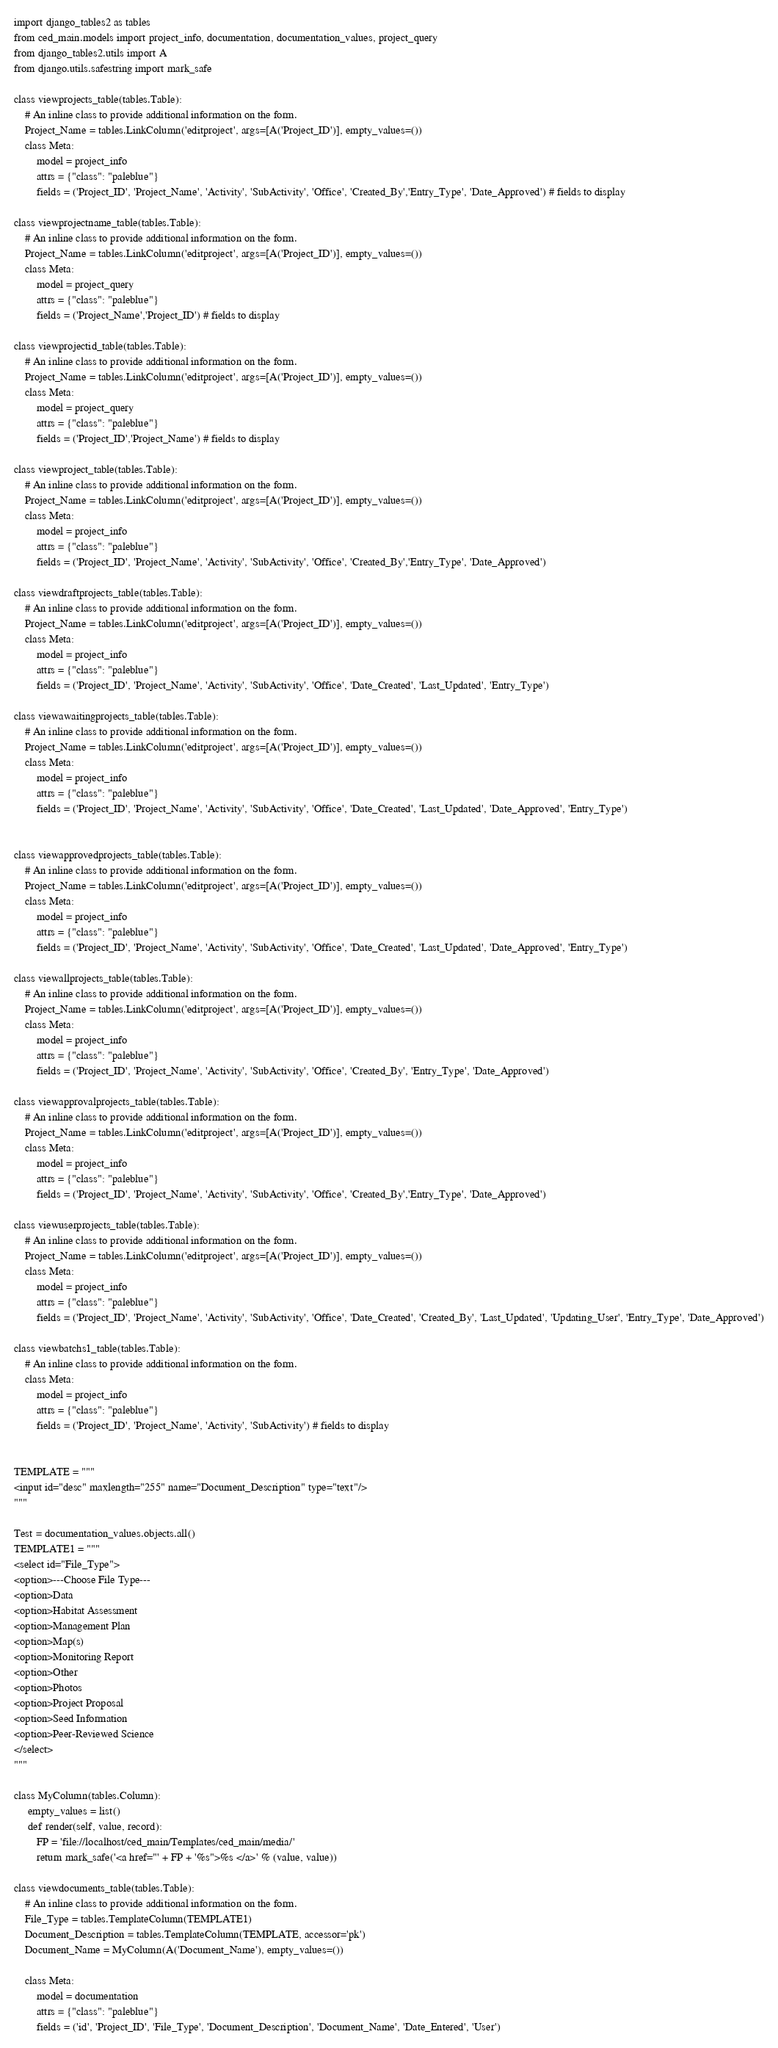<code> <loc_0><loc_0><loc_500><loc_500><_Python_>import django_tables2 as tables
from ced_main.models import project_info, documentation, documentation_values, project_query
from django_tables2.utils import A
from django.utils.safestring import mark_safe

class viewprojects_table(tables.Table):
    # An inline class to provide additional information on the form.
    Project_Name = tables.LinkColumn('editproject', args=[A('Project_ID')], empty_values=())
    class Meta:
        model = project_info
        attrs = {"class": "paleblue"}
        fields = ('Project_ID', 'Project_Name', 'Activity', 'SubActivity', 'Office', 'Created_By','Entry_Type', 'Date_Approved') # fields to display

class viewprojectname_table(tables.Table):
    # An inline class to provide additional information on the form.
    Project_Name = tables.LinkColumn('editproject', args=[A('Project_ID')], empty_values=())
    class Meta:
        model = project_query
        attrs = {"class": "paleblue"}
        fields = ('Project_Name','Project_ID') # fields to display

class viewprojectid_table(tables.Table):
    # An inline class to provide additional information on the form.
    Project_Name = tables.LinkColumn('editproject', args=[A('Project_ID')], empty_values=())
    class Meta:
        model = project_query
        attrs = {"class": "paleblue"}
        fields = ('Project_ID','Project_Name') # fields to display

class viewproject_table(tables.Table):
    # An inline class to provide additional information on the form.
    Project_Name = tables.LinkColumn('editproject', args=[A('Project_ID')], empty_values=())
    class Meta:
        model = project_info
        attrs = {"class": "paleblue"}
        fields = ('Project_ID', 'Project_Name', 'Activity', 'SubActivity', 'Office', 'Created_By','Entry_Type', 'Date_Approved')

class viewdraftprojects_table(tables.Table):
    # An inline class to provide additional information on the form.
    Project_Name = tables.LinkColumn('editproject', args=[A('Project_ID')], empty_values=())
    class Meta:
        model = project_info
        attrs = {"class": "paleblue"}
        fields = ('Project_ID', 'Project_Name', 'Activity', 'SubActivity', 'Office', 'Date_Created', 'Last_Updated', 'Entry_Type')

class viewawaitingprojects_table(tables.Table):
    # An inline class to provide additional information on the form.
    Project_Name = tables.LinkColumn('editproject', args=[A('Project_ID')], empty_values=())
    class Meta:
        model = project_info
        attrs = {"class": "paleblue"}
        fields = ('Project_ID', 'Project_Name', 'Activity', 'SubActivity', 'Office', 'Date_Created', 'Last_Updated', 'Date_Approved', 'Entry_Type')


class viewapprovedprojects_table(tables.Table):
    # An inline class to provide additional information on the form.
    Project_Name = tables.LinkColumn('editproject', args=[A('Project_ID')], empty_values=())
    class Meta:
        model = project_info
        attrs = {"class": "paleblue"}
        fields = ('Project_ID', 'Project_Name', 'Activity', 'SubActivity', 'Office', 'Date_Created', 'Last_Updated', 'Date_Approved', 'Entry_Type')

class viewallprojects_table(tables.Table):
    # An inline class to provide additional information on the form.
    Project_Name = tables.LinkColumn('editproject', args=[A('Project_ID')], empty_values=())
    class Meta:
        model = project_info
        attrs = {"class": "paleblue"}
        fields = ('Project_ID', 'Project_Name', 'Activity', 'SubActivity', 'Office', 'Created_By', 'Entry_Type', 'Date_Approved')

class viewapprovalprojects_table(tables.Table):
    # An inline class to provide additional information on the form.
    Project_Name = tables.LinkColumn('editproject', args=[A('Project_ID')], empty_values=())
    class Meta:
        model = project_info
        attrs = {"class": "paleblue"}
        fields = ('Project_ID', 'Project_Name', 'Activity', 'SubActivity', 'Office', 'Created_By','Entry_Type', 'Date_Approved')

class viewuserprojects_table(tables.Table):
    # An inline class to provide additional information on the form.
    Project_Name = tables.LinkColumn('editproject', args=[A('Project_ID')], empty_values=())
    class Meta:
        model = project_info
        attrs = {"class": "paleblue"}
        fields = ('Project_ID', 'Project_Name', 'Activity', 'SubActivity', 'Office', 'Date_Created', 'Created_By', 'Last_Updated', 'Updating_User', 'Entry_Type', 'Date_Approved')

class viewbatchs1_table(tables.Table):
    # An inline class to provide additional information on the form.
    class Meta:
        model = project_info
        attrs = {"class": "paleblue"}
        fields = ('Project_ID', 'Project_Name', 'Activity', 'SubActivity') # fields to display


TEMPLATE = """
<input id="desc" maxlength="255" name="Document_Description" type="text"/>
"""

Test = documentation_values.objects.all()
TEMPLATE1 = """
<select id="File_Type">
<option>---Choose File Type---
<option>Data
<option>Habitat Assessment
<option>Management Plan
<option>Map(s)
<option>Monitoring Report
<option>Other
<option>Photos
<option>Project Proposal
<option>Seed Information
<option>Peer-Reviewed Science
</select>
"""

class MyColumn(tables.Column):
     empty_values = list()
     def render(self, value, record):
        FP = 'file://localhost/ced_main/Templates/ced_main/media/'
        return mark_safe('<a href="' + FP + '%s">%s </a>' % (value, value))

class viewdocuments_table(tables.Table):
    # An inline class to provide additional information on the form.
    File_Type = tables.TemplateColumn(TEMPLATE1)
    Document_Description = tables.TemplateColumn(TEMPLATE, accessor='pk')
    Document_Name = MyColumn(A('Document_Name'), empty_values=())

    class Meta:
        model = documentation
        attrs = {"class": "paleblue"}
        fields = ('id', 'Project_ID', 'File_Type', 'Document_Description', 'Document_Name', 'Date_Entered', 'User')</code> 